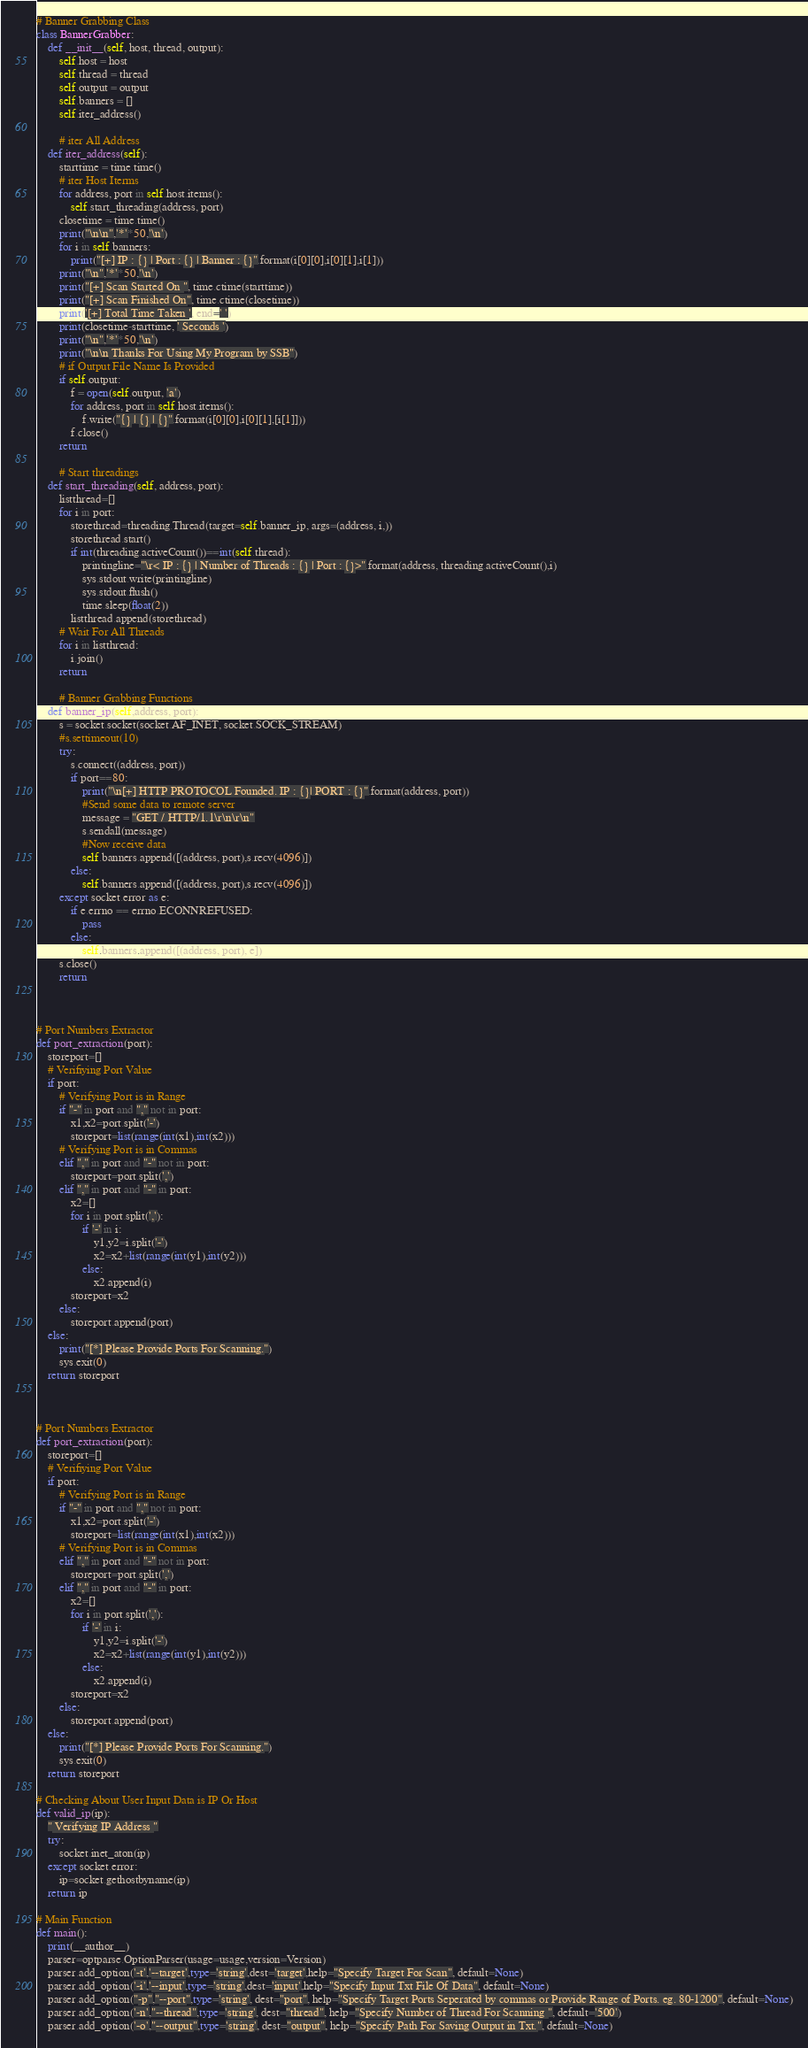Convert code to text. <code><loc_0><loc_0><loc_500><loc_500><_Python_>
# Banner Grabbing Class
class BannerGrabber:
    def __init__(self, host, thread, output):
        self.host = host
        self.thread = thread
        self.output = output
        self.banners = []
        self.iter_address()

        # iter All Address
    def iter_address(self):
        starttime = time.time()
        # iter Host Iterms
        for address, port in self.host.items():
            self.start_threading(address, port)
        closetime = time.time()
        print("\n\n",'*'*50,'\n')
        for i in self.banners:
            print("[+] IP : {} | Port : {} | Banner : {}".format(i[0][0],i[0][1],i[1]))
        print("\n",'*'*50,'\n')
        print("[+] Scan Started On ", time.ctime(starttime))
        print("[+] Scan Finished On", time.ctime(closetime))            
        print('[+] Total Time Taken ', end=' ')
        print(closetime-starttime, ' Seconds ')
        print("\n",'*'*50,'\n')
        print("\n\n Thanks For Using My Program by SSB")
        # if Output File Name Is Provided
        if self.output:
            f = open(self.output, 'a')
            for address, port in self.host.items():
                f.write("{} | {} | {}".format(i[0][0],i[0][1],[i[1]]))
            f.close() 
        return

        # Start threadings
    def start_threading(self, address, port):
        listthread=[]
        for i in port:
            storethread=threading.Thread(target=self.banner_ip, args=(address, i,))
            storethread.start()
            if int(threading.activeCount())==int(self.thread):
                printingline="\r< IP : {} | Number of Threads : {} | Port : {}>".format(address, threading.activeCount(),i)
                sys.stdout.write(printingline)
                sys.stdout.flush()
                time.sleep(float(2))
            listthread.append(storethread)
        # Wait For All Threads
        for i in listthread:
            i.join()
        return

        # Banner Grabbing Functions
    def banner_ip(self,address, port):
        s = socket.socket(socket.AF_INET, socket.SOCK_STREAM)
        #s.settimeout(10)
        try:
            s.connect((address, port))
            if port==80:
                print("\n[+] HTTP PROTOCOL Founded. IP : {}| PORT : {}".format(address, port))
                #Send some data to remote server
                message = "GET / HTTP/1.1\r\n\r\n"
                s.sendall(message)
                #Now receive data
                self.banners.append([(address, port),s.recv(4096)])
            else:
                self.banners.append([(address, port),s.recv(4096)])
        except socket.error as e:
            if e.errno == errno.ECONNREFUSED:
                pass
            else:
                self.banners.append([(address, port), e])
        s.close()
        return 



# Port Numbers Extractor
def port_extraction(port):
    storeport=[]
    # Verifiying Port Value
    if port:
        # Verifying Port is in Range
        if "-" in port and "," not in port:
            x1,x2=port.split('-')
            storeport=list(range(int(x1),int(x2)))
        # Verifying Port is in Commas
        elif "," in port and "-" not in port:
            storeport=port.split(',')
        elif "," in port and "-" in port:
            x2=[]
            for i in port.split(','):
                if '-' in i:
                    y1,y2=i.split('-')
                    x2=x2+list(range(int(y1),int(y2)))
                else:
                    x2.append(i)
            storeport=x2
        else:
            storeport.append(port)
    else:
        print("[*] Please Provide Ports For Scanning.")
        sys.exit(0)
    return storeport



# Port Numbers Extractor
def port_extraction(port):
    storeport=[]
    # Verifiying Port Value
    if port:
        # Verifying Port is in Range
        if "-" in port and "," not in port:
            x1,x2=port.split('-')
            storeport=list(range(int(x1),int(x2)))
        # Verifying Port is in Commas
        elif "," in port and "-" not in port:
            storeport=port.split(',')
        elif "," in port and "-" in port:
            x2=[]
            for i in port.split(','):
                if '-' in i:
                    y1,y2=i.split('-')
                    x2=x2+list(range(int(y1),int(y2)))
                else:
                    x2.append(i)
            storeport=x2
        else:
            storeport.append(port)
    else:
        print("[*] Please Provide Ports For Scanning.")
        sys.exit(0)
    return storeport

# Checking About User Input Data is IP Or Host
def valid_ip(ip):
    " Verifying IP Address "
    try:
        socket.inet_aton(ip)
    except socket.error:
        ip=socket.gethostbyname(ip)
    return ip

# Main Function
def main():
    print(__author__)
    parser=optparse.OptionParser(usage=usage,version=Version)
    parser.add_option('-t','--target',type='string',dest='target',help="Specify Target For Scan", default=None)
    parser.add_option('-i','--input',type='string',dest='input',help="Specify Input Txt File Of Data", default=None)
    parser.add_option("-p","--port",type='string', dest="port", help="Specify Target Ports Seperated by commas or Provide Range of Ports. eg. 80-1200", default=None)
    parser.add_option('-n',"--thread",type='string', dest="thread", help="Specify Number of Thread For Scanning ", default='500')
    parser.add_option('-o',"--output",type='string', dest="output", help="Specify Path For Saving Output in Txt.", default=None)</code> 